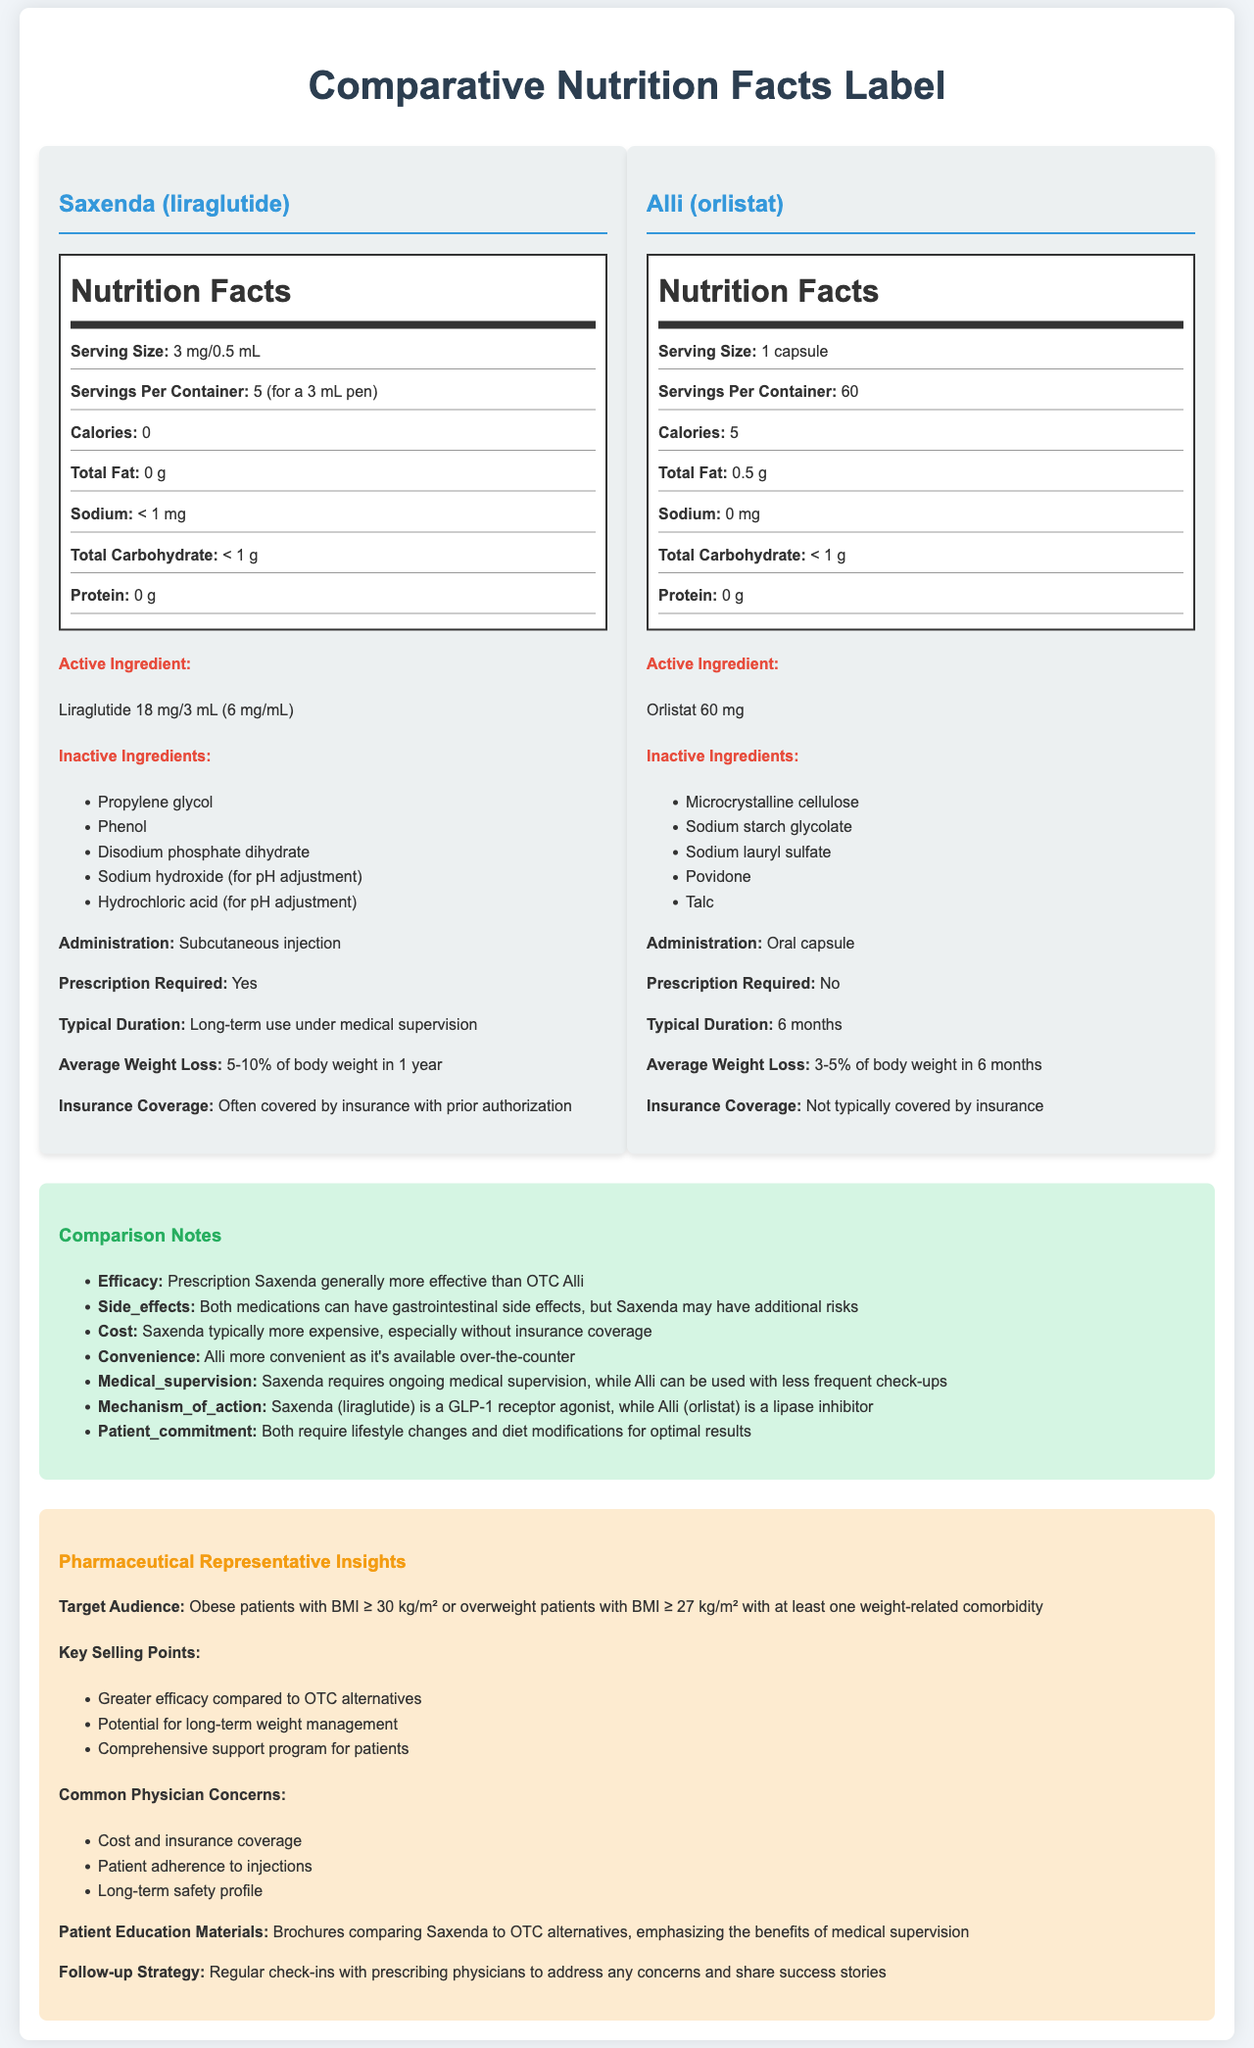what is the serving size for Saxenda? The serving size for Saxenda is explicitly listed as 3 mg/0.5 mL in the document.
Answer: 3 mg/0.5 mL which medication requires medical supervision for long-term use? The document states that Saxenda requires long-term use under medical supervision.
Answer: Saxenda how many servings per container are in Alli? Alli has 60 servings per container as specified in the document.
Answer: 60 what is the average weight loss for Saxenda in one year? The document indicates that the average weight loss for Saxenda is 5-10% of body weight in 1 year.
Answer: 5-10% of body weight what is the administration route for Alli? Alli is administered as an oral capsule, according to the document.
Answer: Oral capsule which product is generally more effective according to the comparison notes? A. Saxenda B. Alli C. Both are equally effective The document mentions that prescription Saxenda is generally more effective than OTC Alli.
Answer: A what is the active ingredient in Alli? A. Liraglutide B. Orlistat C. Microcrystalline cellulose D. Sodium valproate The active ingredient in Alli is Orlistat 60 mg, as indicated in the document.
Answer: B is Saxenda covered by insurance? The document states that Saxenda is often covered by insurance with prior authorization.
Answer: Often covered by insurance with prior authorization describe the main idea of the document. The detailed comparative nature of the document allows individuals to assess the differences and similarities between these two weight loss medications, aiding in informed decision-making.
Answer: The document is a comparative nutrition facts label for Saxenda (a prescription weight loss medication) and Alli (an over-the-counter alternative). It provides nutritional information, active and inactive ingredients, administration details, and key comparison notes about efficacy, side effects, cost, convenience, and patient commitment. Additionally, it offers insights from a pharmaceutical representative for targeting and addressing common physician concerns. which medication has additional gastrointestinal side effects? The comparison notes section indicates that both medications can have gastrointestinal side effects, though Saxenda may have additional risks.
Answer: Both how many calories does Saxenda contain? According to the nutrition facts for Saxenda, it contains 0 calories.
Answer: 0 which product is not typically covered by insurance? The document states that the over-the-counter alternative, Alli, is not typically covered by insurance.
Answer: Alli what is the mechanism of action for Saxenda? The comparison notes indicate that Saxenda (liraglutide) is a GLP-1 receptor agonist.
Answer: GLP-1 receptor agonist what is the difference in typical duration between Saxenda and Alli? The document explains that Saxenda requires long-term use under medical supervision, while Alli is typically used for 6 months.
Answer: Saxenda's typical duration is long-term under medical supervision, whereas Alli's typical duration is 6 months. list one common physician concern for prescribing Saxenda. One of the common physician concerns mentioned in the pharmaceutical rep insights is cost and insurance coverage.
Answer: Cost and insurance coverage what specific inactive ingredient is listed for both medications? There are no inactive ingredients listed in the document that are common to both medications.
Answer: None does the document provide the cost of Saxenda? The document does not provide the specific cost of Saxenda.
Answer: Not enough information 